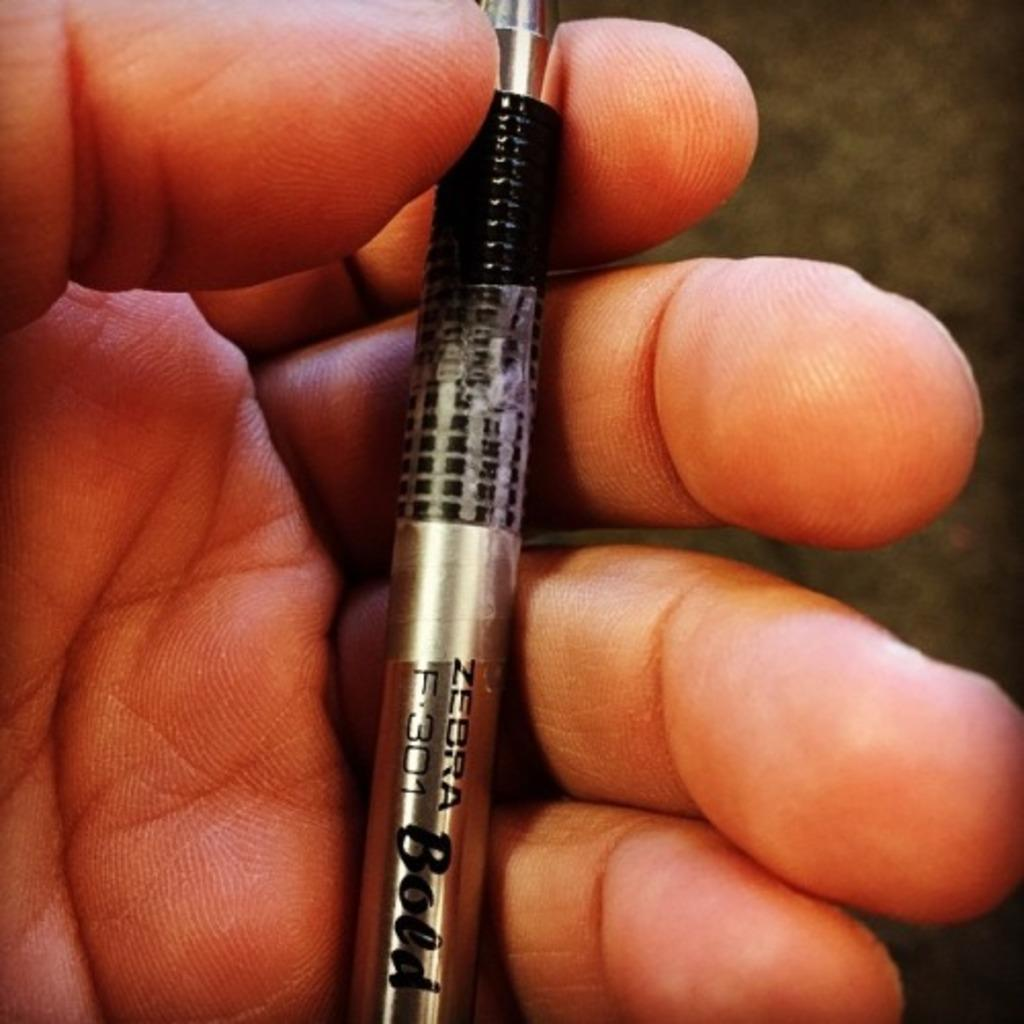What is the main subject of the image? The main subject of the image is a human hand. What is the hand holding in the image? The hand is holding a pen. What type of body is visible in the image? There is no body visible in the image, only a human hand holding a pen. What is the hand hoping to achieve in the image? The image does not provide any information about the hand's intentions or hopes. 